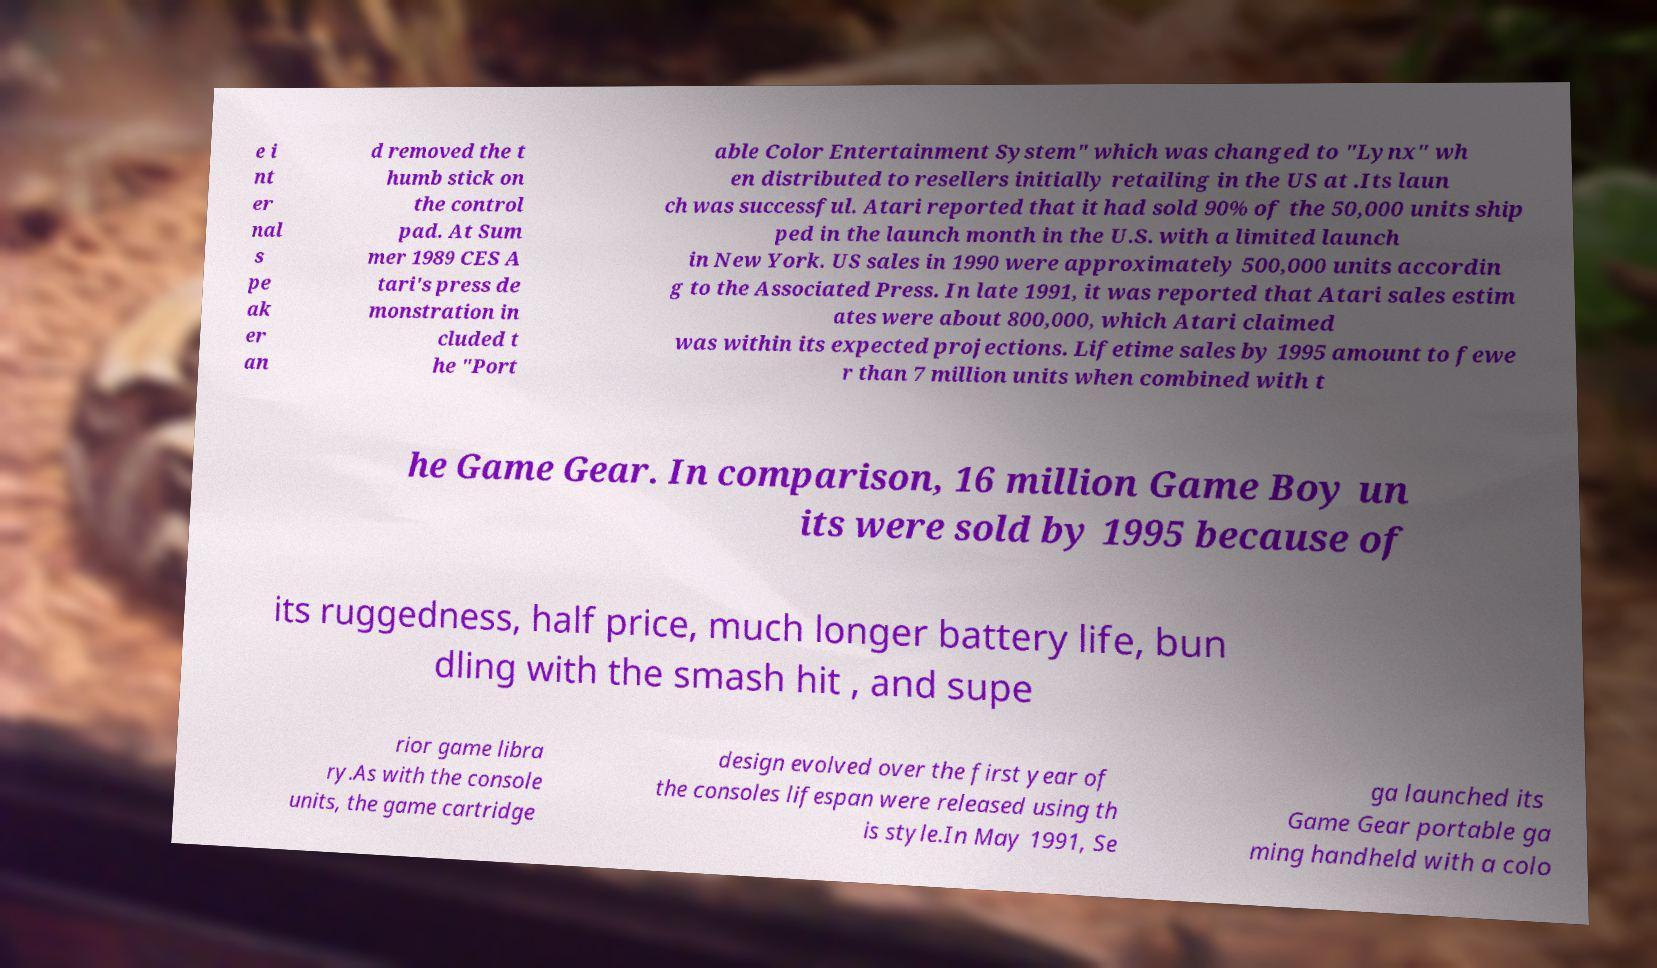Please identify and transcribe the text found in this image. e i nt er nal s pe ak er an d removed the t humb stick on the control pad. At Sum mer 1989 CES A tari's press de monstration in cluded t he "Port able Color Entertainment System" which was changed to "Lynx" wh en distributed to resellers initially retailing in the US at .Its laun ch was successful. Atari reported that it had sold 90% of the 50,000 units ship ped in the launch month in the U.S. with a limited launch in New York. US sales in 1990 were approximately 500,000 units accordin g to the Associated Press. In late 1991, it was reported that Atari sales estim ates were about 800,000, which Atari claimed was within its expected projections. Lifetime sales by 1995 amount to fewe r than 7 million units when combined with t he Game Gear. In comparison, 16 million Game Boy un its were sold by 1995 because of its ruggedness, half price, much longer battery life, bun dling with the smash hit , and supe rior game libra ry.As with the console units, the game cartridge design evolved over the first year of the consoles lifespan were released using th is style.In May 1991, Se ga launched its Game Gear portable ga ming handheld with a colo 